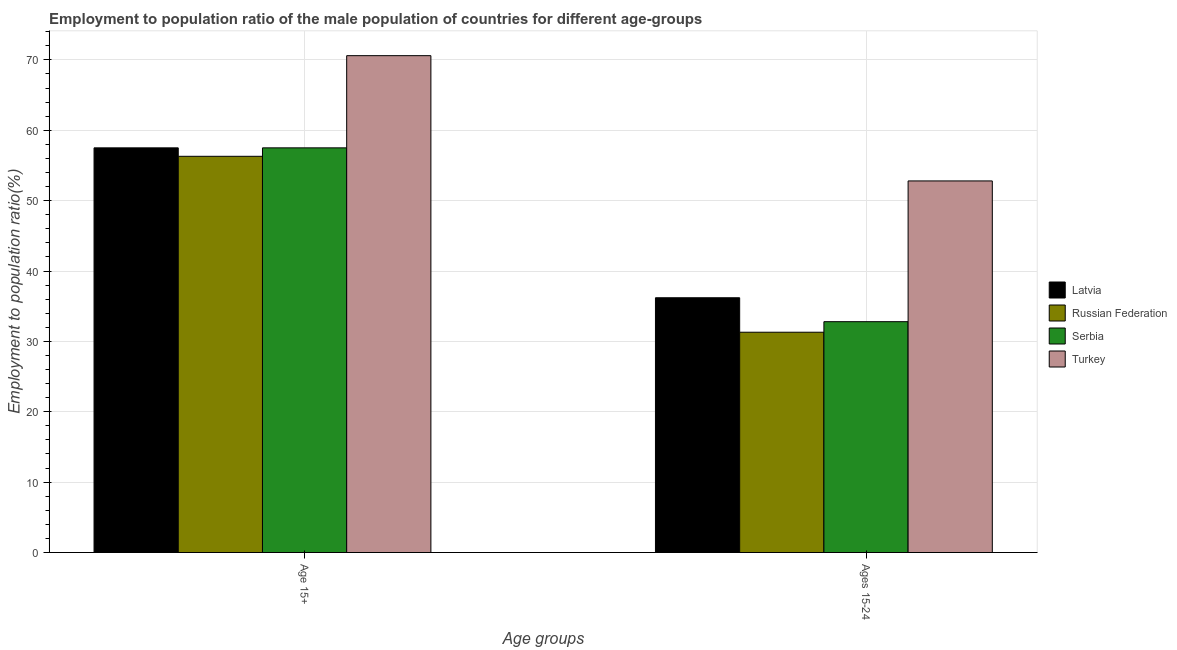How many different coloured bars are there?
Provide a short and direct response. 4. How many groups of bars are there?
Make the answer very short. 2. Are the number of bars per tick equal to the number of legend labels?
Keep it short and to the point. Yes. How many bars are there on the 2nd tick from the left?
Provide a short and direct response. 4. How many bars are there on the 2nd tick from the right?
Make the answer very short. 4. What is the label of the 2nd group of bars from the left?
Provide a succinct answer. Ages 15-24. What is the employment to population ratio(age 15+) in Serbia?
Your answer should be compact. 57.5. Across all countries, what is the maximum employment to population ratio(age 15+)?
Provide a succinct answer. 70.6. Across all countries, what is the minimum employment to population ratio(age 15-24)?
Offer a very short reply. 31.3. In which country was the employment to population ratio(age 15-24) minimum?
Give a very brief answer. Russian Federation. What is the total employment to population ratio(age 15+) in the graph?
Ensure brevity in your answer.  241.9. What is the difference between the employment to population ratio(age 15-24) in Serbia and that in Latvia?
Give a very brief answer. -3.4. What is the difference between the employment to population ratio(age 15+) in Latvia and the employment to population ratio(age 15-24) in Turkey?
Provide a short and direct response. 4.7. What is the average employment to population ratio(age 15+) per country?
Your response must be concise. 60.47. What is the difference between the employment to population ratio(age 15-24) and employment to population ratio(age 15+) in Serbia?
Keep it short and to the point. -24.7. What is the ratio of the employment to population ratio(age 15-24) in Latvia to that in Serbia?
Offer a very short reply. 1.1. What does the 2nd bar from the left in Ages 15-24 represents?
Make the answer very short. Russian Federation. What does the 3rd bar from the right in Age 15+ represents?
Give a very brief answer. Russian Federation. How many bars are there?
Ensure brevity in your answer.  8. What is the difference between two consecutive major ticks on the Y-axis?
Your answer should be compact. 10. Does the graph contain any zero values?
Keep it short and to the point. No. Where does the legend appear in the graph?
Your response must be concise. Center right. How many legend labels are there?
Offer a very short reply. 4. What is the title of the graph?
Your response must be concise. Employment to population ratio of the male population of countries for different age-groups. What is the label or title of the X-axis?
Keep it short and to the point. Age groups. What is the label or title of the Y-axis?
Your answer should be very brief. Employment to population ratio(%). What is the Employment to population ratio(%) of Latvia in Age 15+?
Your answer should be compact. 57.5. What is the Employment to population ratio(%) in Russian Federation in Age 15+?
Offer a very short reply. 56.3. What is the Employment to population ratio(%) in Serbia in Age 15+?
Give a very brief answer. 57.5. What is the Employment to population ratio(%) of Turkey in Age 15+?
Offer a terse response. 70.6. What is the Employment to population ratio(%) of Latvia in Ages 15-24?
Make the answer very short. 36.2. What is the Employment to population ratio(%) of Russian Federation in Ages 15-24?
Keep it short and to the point. 31.3. What is the Employment to population ratio(%) of Serbia in Ages 15-24?
Give a very brief answer. 32.8. What is the Employment to population ratio(%) in Turkey in Ages 15-24?
Keep it short and to the point. 52.8. Across all Age groups, what is the maximum Employment to population ratio(%) in Latvia?
Your response must be concise. 57.5. Across all Age groups, what is the maximum Employment to population ratio(%) in Russian Federation?
Keep it short and to the point. 56.3. Across all Age groups, what is the maximum Employment to population ratio(%) of Serbia?
Give a very brief answer. 57.5. Across all Age groups, what is the maximum Employment to population ratio(%) of Turkey?
Ensure brevity in your answer.  70.6. Across all Age groups, what is the minimum Employment to population ratio(%) in Latvia?
Ensure brevity in your answer.  36.2. Across all Age groups, what is the minimum Employment to population ratio(%) of Russian Federation?
Offer a very short reply. 31.3. Across all Age groups, what is the minimum Employment to population ratio(%) in Serbia?
Ensure brevity in your answer.  32.8. Across all Age groups, what is the minimum Employment to population ratio(%) in Turkey?
Provide a short and direct response. 52.8. What is the total Employment to population ratio(%) in Latvia in the graph?
Provide a succinct answer. 93.7. What is the total Employment to population ratio(%) in Russian Federation in the graph?
Ensure brevity in your answer.  87.6. What is the total Employment to population ratio(%) in Serbia in the graph?
Offer a terse response. 90.3. What is the total Employment to population ratio(%) in Turkey in the graph?
Offer a terse response. 123.4. What is the difference between the Employment to population ratio(%) of Latvia in Age 15+ and that in Ages 15-24?
Your response must be concise. 21.3. What is the difference between the Employment to population ratio(%) of Russian Federation in Age 15+ and that in Ages 15-24?
Offer a terse response. 25. What is the difference between the Employment to population ratio(%) of Serbia in Age 15+ and that in Ages 15-24?
Your response must be concise. 24.7. What is the difference between the Employment to population ratio(%) of Turkey in Age 15+ and that in Ages 15-24?
Offer a terse response. 17.8. What is the difference between the Employment to population ratio(%) of Latvia in Age 15+ and the Employment to population ratio(%) of Russian Federation in Ages 15-24?
Your response must be concise. 26.2. What is the difference between the Employment to population ratio(%) in Latvia in Age 15+ and the Employment to population ratio(%) in Serbia in Ages 15-24?
Your answer should be very brief. 24.7. What is the difference between the Employment to population ratio(%) in Russian Federation in Age 15+ and the Employment to population ratio(%) in Serbia in Ages 15-24?
Ensure brevity in your answer.  23.5. What is the difference between the Employment to population ratio(%) in Russian Federation in Age 15+ and the Employment to population ratio(%) in Turkey in Ages 15-24?
Your answer should be very brief. 3.5. What is the average Employment to population ratio(%) in Latvia per Age groups?
Keep it short and to the point. 46.85. What is the average Employment to population ratio(%) of Russian Federation per Age groups?
Your response must be concise. 43.8. What is the average Employment to population ratio(%) in Serbia per Age groups?
Keep it short and to the point. 45.15. What is the average Employment to population ratio(%) of Turkey per Age groups?
Your response must be concise. 61.7. What is the difference between the Employment to population ratio(%) in Latvia and Employment to population ratio(%) in Serbia in Age 15+?
Your answer should be compact. 0. What is the difference between the Employment to population ratio(%) in Russian Federation and Employment to population ratio(%) in Serbia in Age 15+?
Provide a succinct answer. -1.2. What is the difference between the Employment to population ratio(%) of Russian Federation and Employment to population ratio(%) of Turkey in Age 15+?
Your answer should be compact. -14.3. What is the difference between the Employment to population ratio(%) of Serbia and Employment to population ratio(%) of Turkey in Age 15+?
Your answer should be compact. -13.1. What is the difference between the Employment to population ratio(%) in Latvia and Employment to population ratio(%) in Serbia in Ages 15-24?
Provide a succinct answer. 3.4. What is the difference between the Employment to population ratio(%) of Latvia and Employment to population ratio(%) of Turkey in Ages 15-24?
Your answer should be very brief. -16.6. What is the difference between the Employment to population ratio(%) in Russian Federation and Employment to population ratio(%) in Serbia in Ages 15-24?
Ensure brevity in your answer.  -1.5. What is the difference between the Employment to population ratio(%) in Russian Federation and Employment to population ratio(%) in Turkey in Ages 15-24?
Ensure brevity in your answer.  -21.5. What is the difference between the Employment to population ratio(%) of Serbia and Employment to population ratio(%) of Turkey in Ages 15-24?
Your response must be concise. -20. What is the ratio of the Employment to population ratio(%) in Latvia in Age 15+ to that in Ages 15-24?
Offer a terse response. 1.59. What is the ratio of the Employment to population ratio(%) of Russian Federation in Age 15+ to that in Ages 15-24?
Provide a succinct answer. 1.8. What is the ratio of the Employment to population ratio(%) of Serbia in Age 15+ to that in Ages 15-24?
Make the answer very short. 1.75. What is the ratio of the Employment to population ratio(%) in Turkey in Age 15+ to that in Ages 15-24?
Your response must be concise. 1.34. What is the difference between the highest and the second highest Employment to population ratio(%) in Latvia?
Make the answer very short. 21.3. What is the difference between the highest and the second highest Employment to population ratio(%) in Serbia?
Give a very brief answer. 24.7. What is the difference between the highest and the second highest Employment to population ratio(%) of Turkey?
Make the answer very short. 17.8. What is the difference between the highest and the lowest Employment to population ratio(%) in Latvia?
Offer a terse response. 21.3. What is the difference between the highest and the lowest Employment to population ratio(%) in Russian Federation?
Your answer should be very brief. 25. What is the difference between the highest and the lowest Employment to population ratio(%) of Serbia?
Provide a succinct answer. 24.7. 